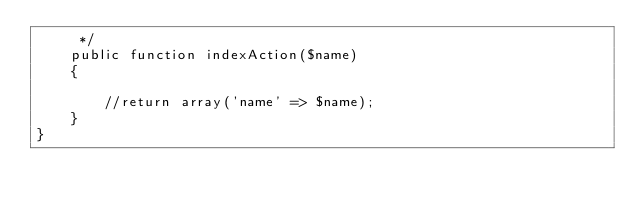<code> <loc_0><loc_0><loc_500><loc_500><_PHP_>     */
    public function indexAction($name)
    {

        //return array('name' => $name);
    }
}
</code> 